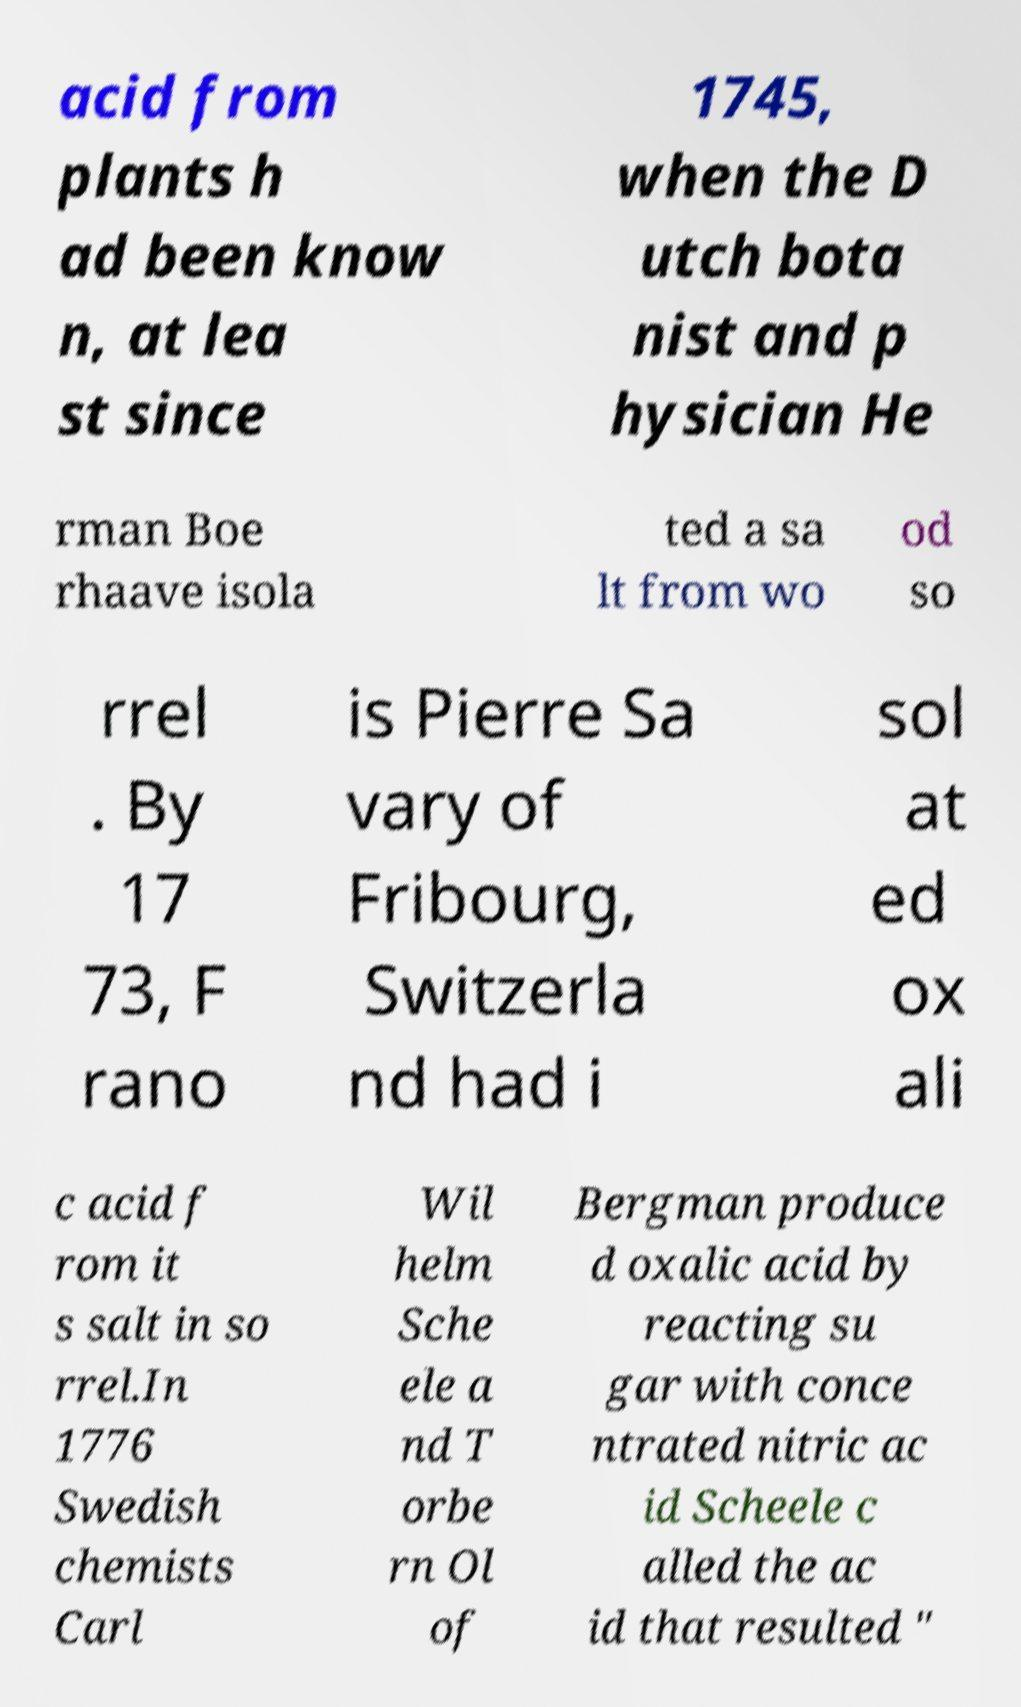Could you extract and type out the text from this image? acid from plants h ad been know n, at lea st since 1745, when the D utch bota nist and p hysician He rman Boe rhaave isola ted a sa lt from wo od so rrel . By 17 73, F rano is Pierre Sa vary of Fribourg, Switzerla nd had i sol at ed ox ali c acid f rom it s salt in so rrel.In 1776 Swedish chemists Carl Wil helm Sche ele a nd T orbe rn Ol of Bergman produce d oxalic acid by reacting su gar with conce ntrated nitric ac id Scheele c alled the ac id that resulted " 